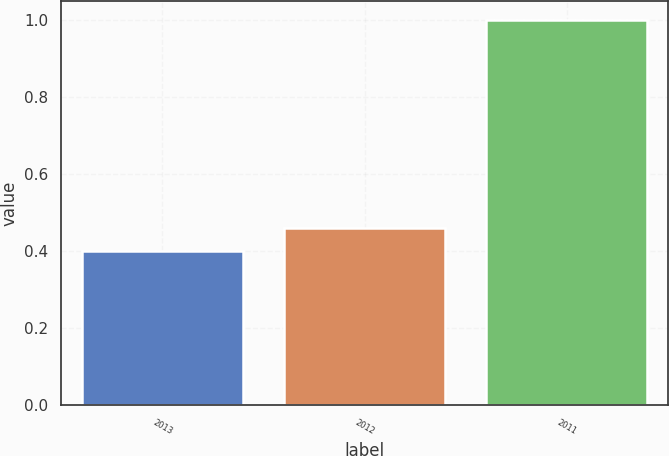Convert chart. <chart><loc_0><loc_0><loc_500><loc_500><bar_chart><fcel>2013<fcel>2012<fcel>2011<nl><fcel>0.4<fcel>0.46<fcel>1<nl></chart> 